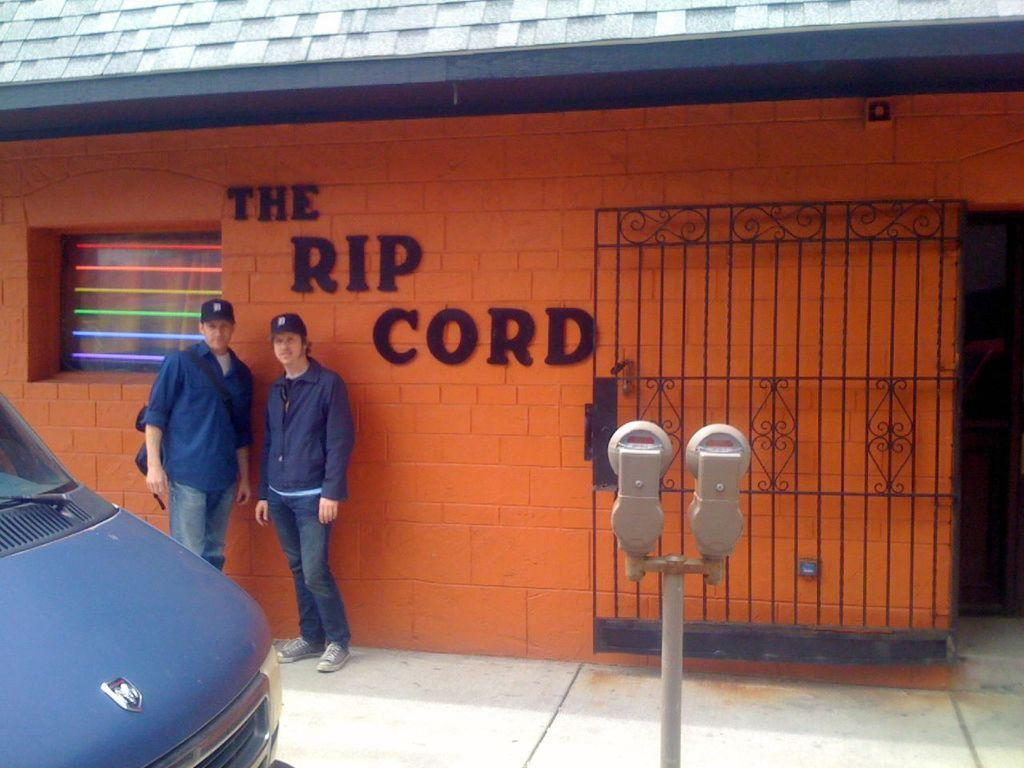How many people are in the image? There are two people in the image. What are the people doing in the image? The people are standing in front of a building. Can you describe the building in the image? The building has a gate. What is in front of the people in the image? There is a car and a pole in front of the people. How many spiders are crawling on the car in the image? There are no spiders visible in the image, so it is not possible to determine how many might be crawling on the car. 